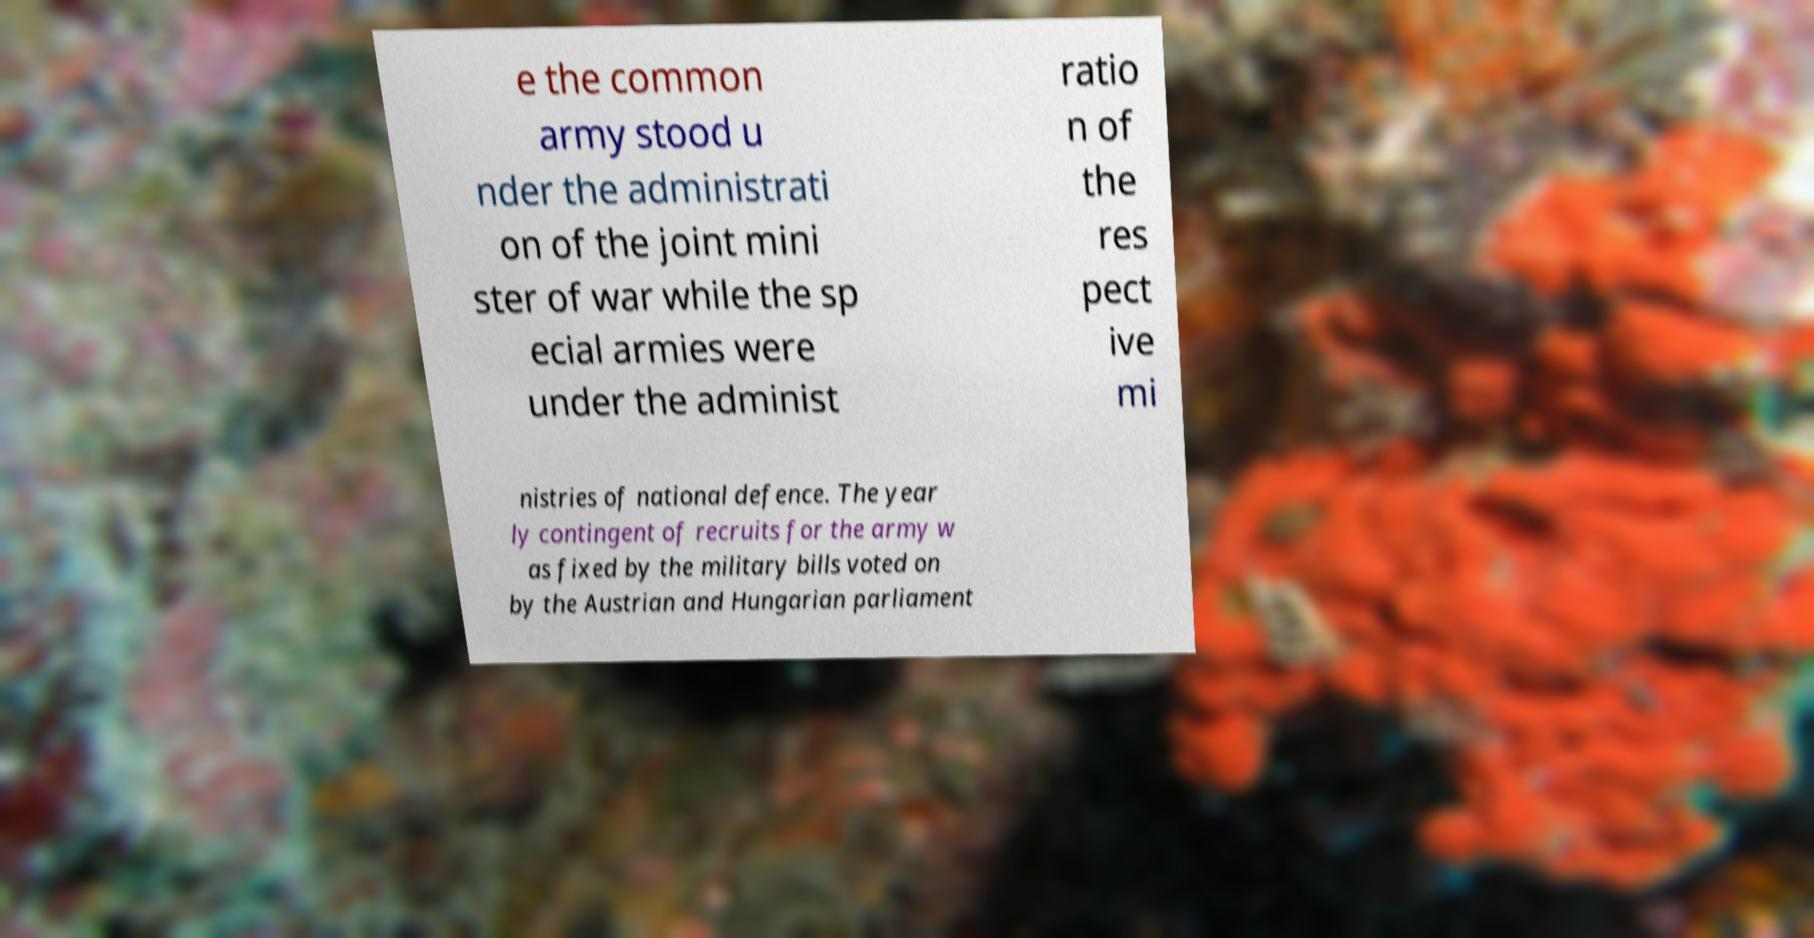Could you extract and type out the text from this image? e the common army stood u nder the administrati on of the joint mini ster of war while the sp ecial armies were under the administ ratio n of the res pect ive mi nistries of national defence. The year ly contingent of recruits for the army w as fixed by the military bills voted on by the Austrian and Hungarian parliament 